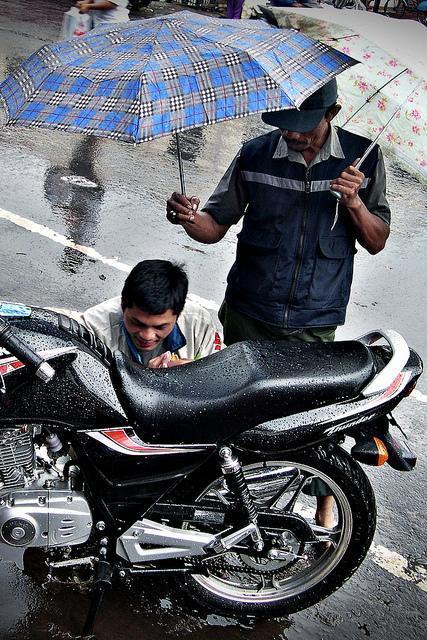How many people are there?
Give a very brief answer. 2. How many umbrellas can be seen?
Give a very brief answer. 2. 